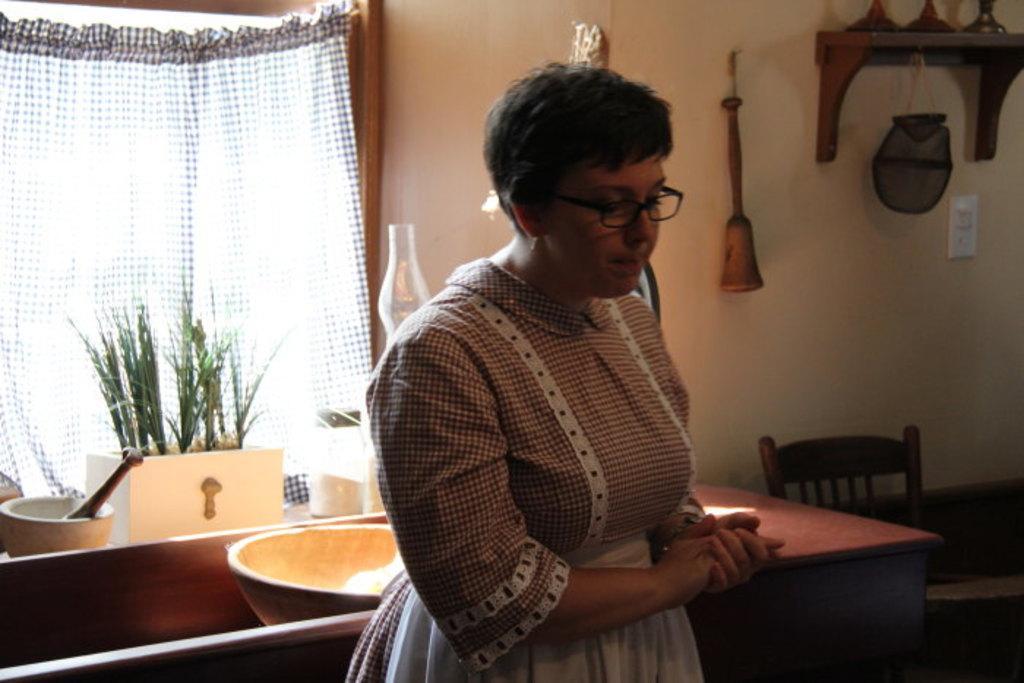Can you describe this image briefly? In this image I can see the person. In the background I can see the table and the chair and I can also see the plant in green color, curtain, window and few objects attached to the wall 